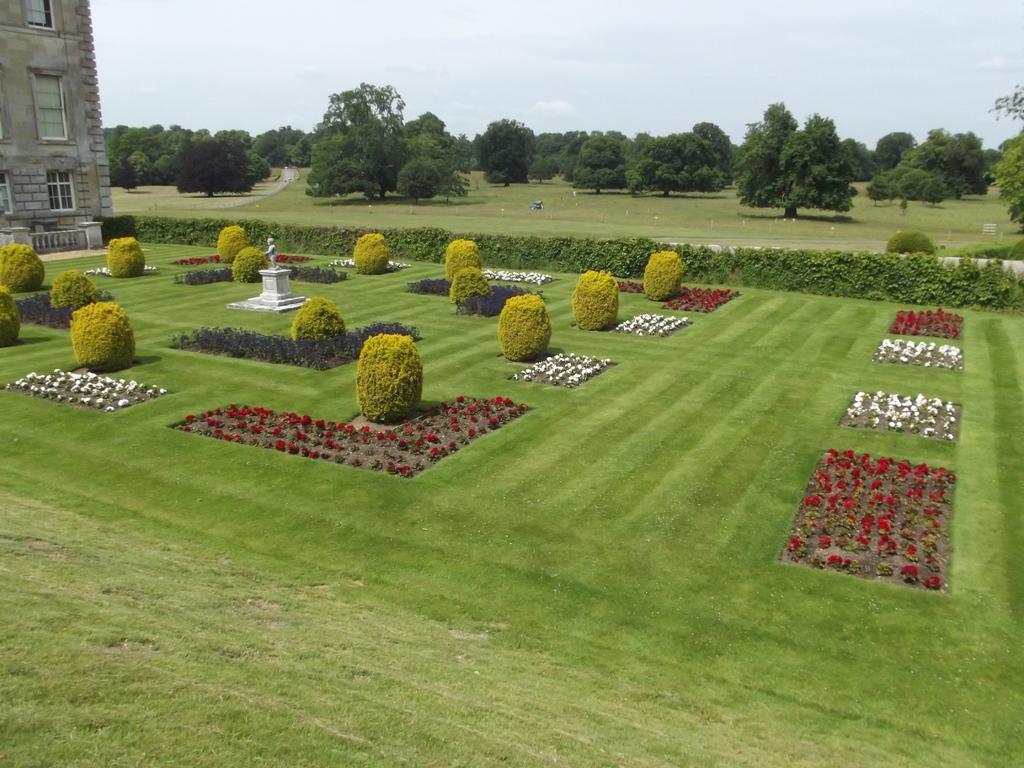How would you summarize this image in a sentence or two? At the bottom of the image we can see bushes and hedges. On the left there is a statue and a building. We can see flower plants. In the background there are trees and sky. 